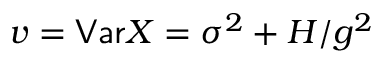<formula> <loc_0><loc_0><loc_500><loc_500>v = V a r X = \sigma ^ { 2 } + H / g ^ { 2 }</formula> 